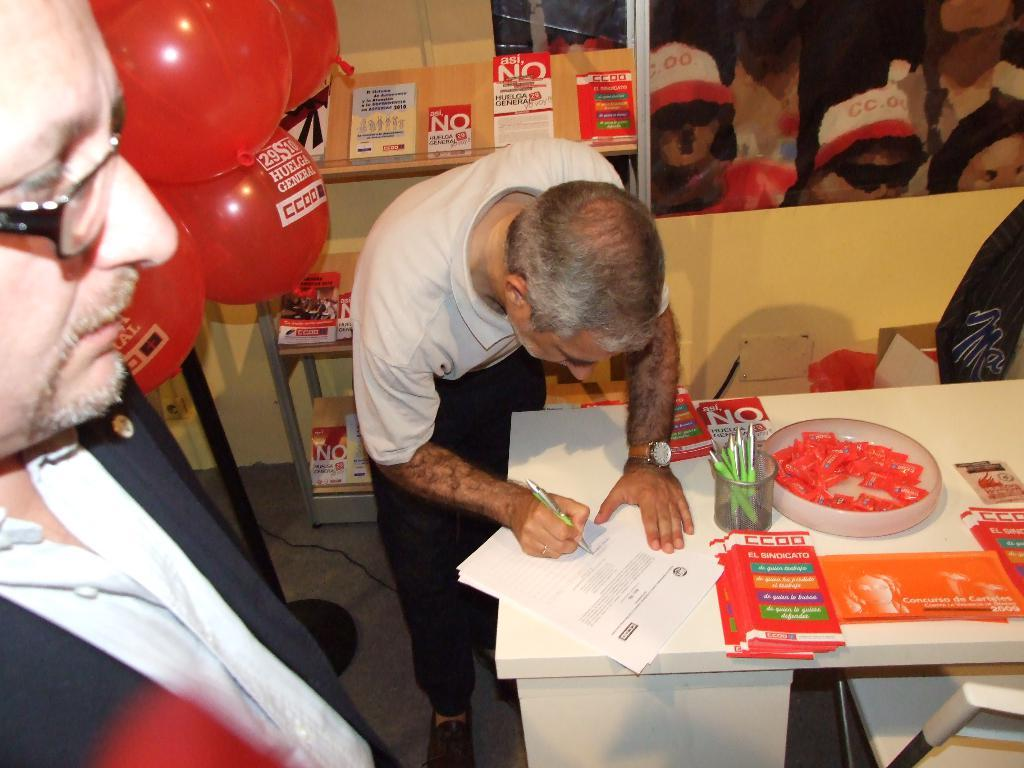What are the people in the image wearing? The people in the image are wearing clothes. What event or activity might be taking place in the image? The presence of a spectacle, a pen, papers, and a container suggests that it could be a meeting or presentation. What time-keeping device is visible in the image? There is a wrist watch in the image. What might be used for writing in the image? There is a pen in the image. What might be used for holding or organizing papers in the image? There is a container in the image. What type of furniture is present in the image? There is a table in the image. What type of surface is visible in the image? There is a floor in the image. What type of electrical connection is visible in the image? There is a cable wire in the image. What might be used for storing or displaying items in the image? There is a shelf in the image. What type of decoration or celebration item is visible in the image? There are balloons in the image. How many doors can be seen in the image? There are no doors visible in the image. What type of currency is present in the image? There is no currency present in the image. What type of clothing is hanging on the coat rack in the image? There is no coat rack or coat present in the image. 